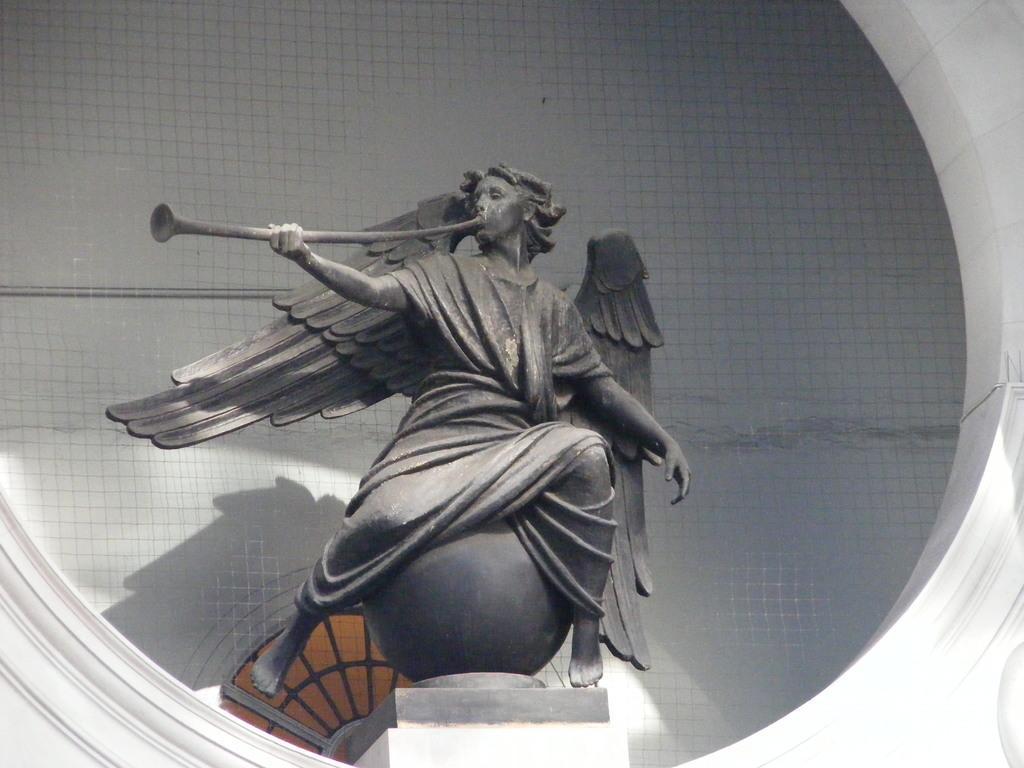Describe this image in one or two sentences. There is a statue holding something in the hand and sitting on a round structure. In the back there is a wall. 